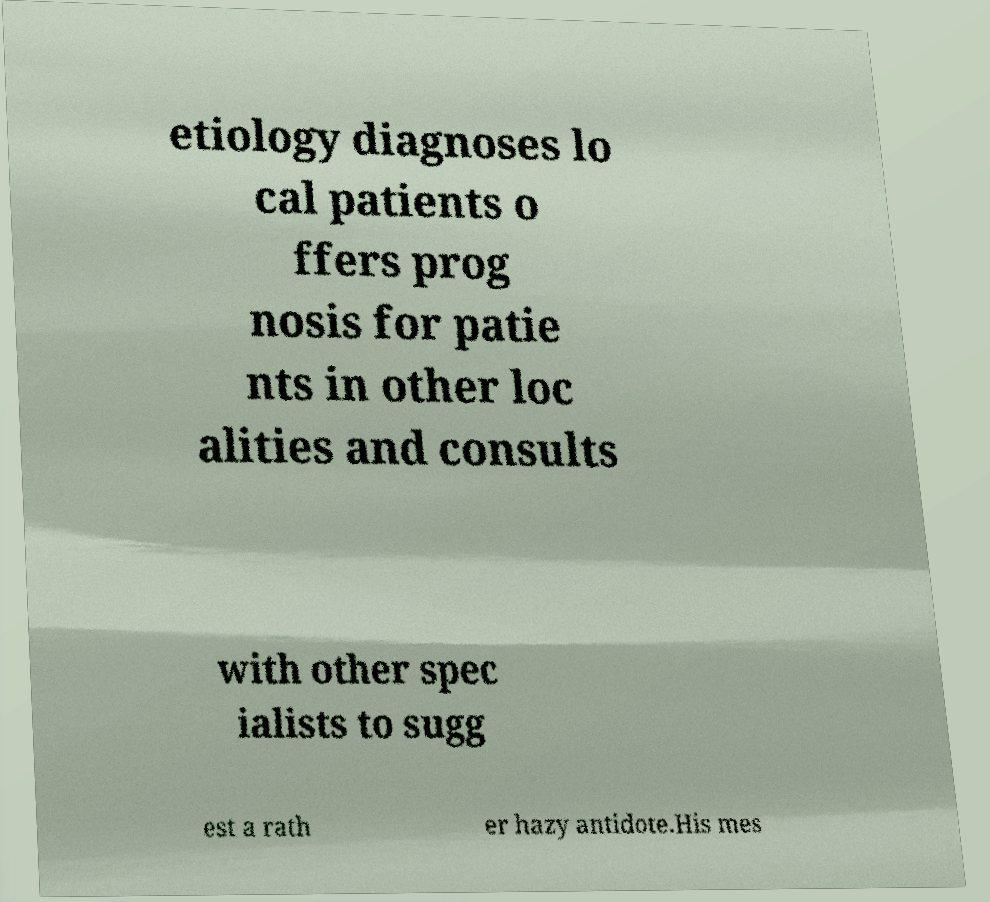What messages or text are displayed in this image? I need them in a readable, typed format. etiology diagnoses lo cal patients o ffers prog nosis for patie nts in other loc alities and consults with other spec ialists to sugg est a rath er hazy antidote.His mes 